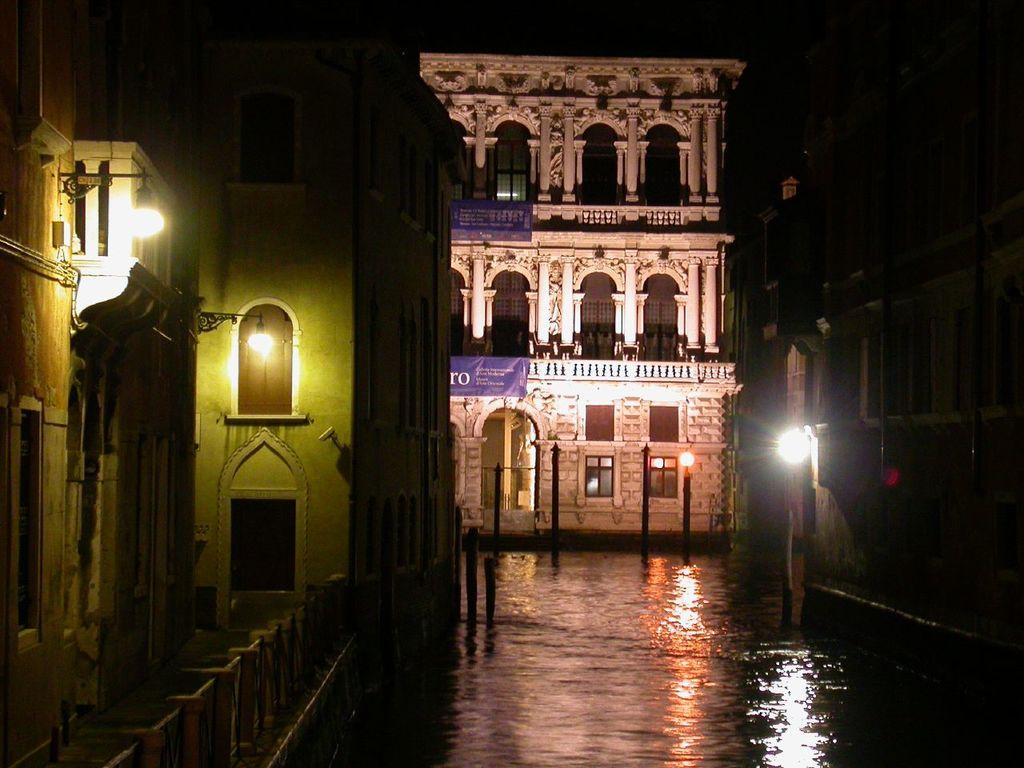What is the primary element visible in the image? There is water in the image. What structures are located near the water? There are buildings beside the water. What type of lighting is present in the image? There are lamp posts in the image. How many goldfish can be seen swimming in the water in the image? There are no goldfish visible in the image; it only features water, buildings, and lamp posts. What type of trousers are the goldfish wearing in the image? There are no goldfish or trousers present in the image. 